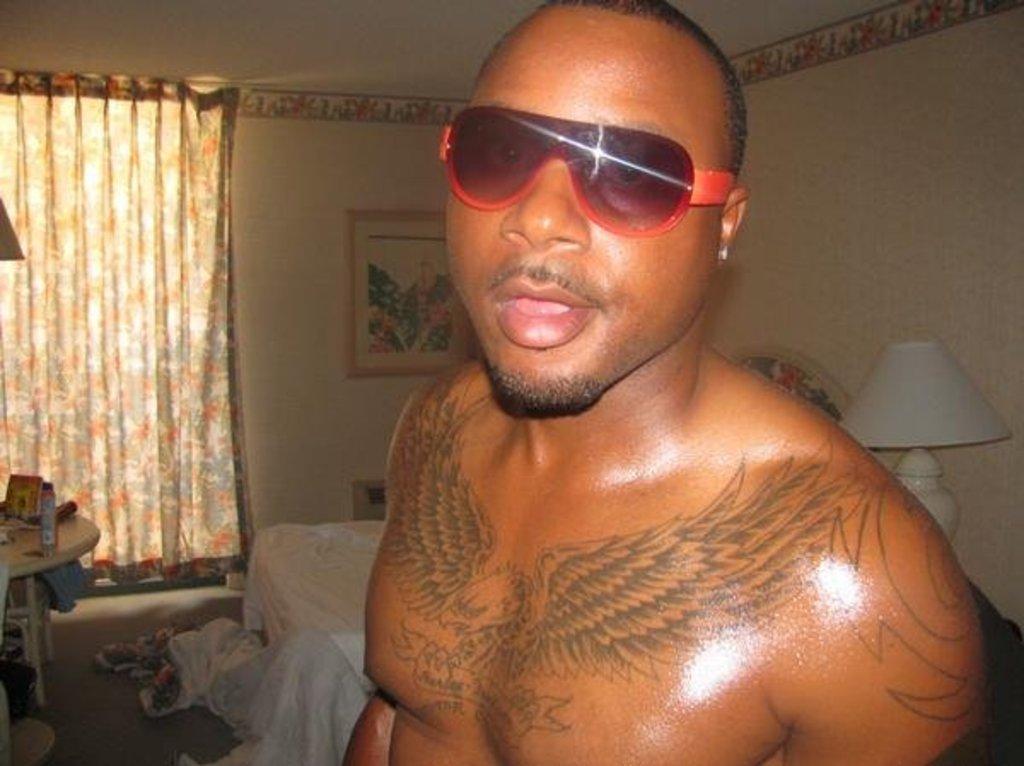Could you give a brief overview of what you see in this image? In this image we can see a man and he has goggles to his eyes. In the background there is a bed sheet, bed, bottle and objects on a table on the left side, clothes on the floor, curtain, frame and objects on the wall and a lamp on the right side. 